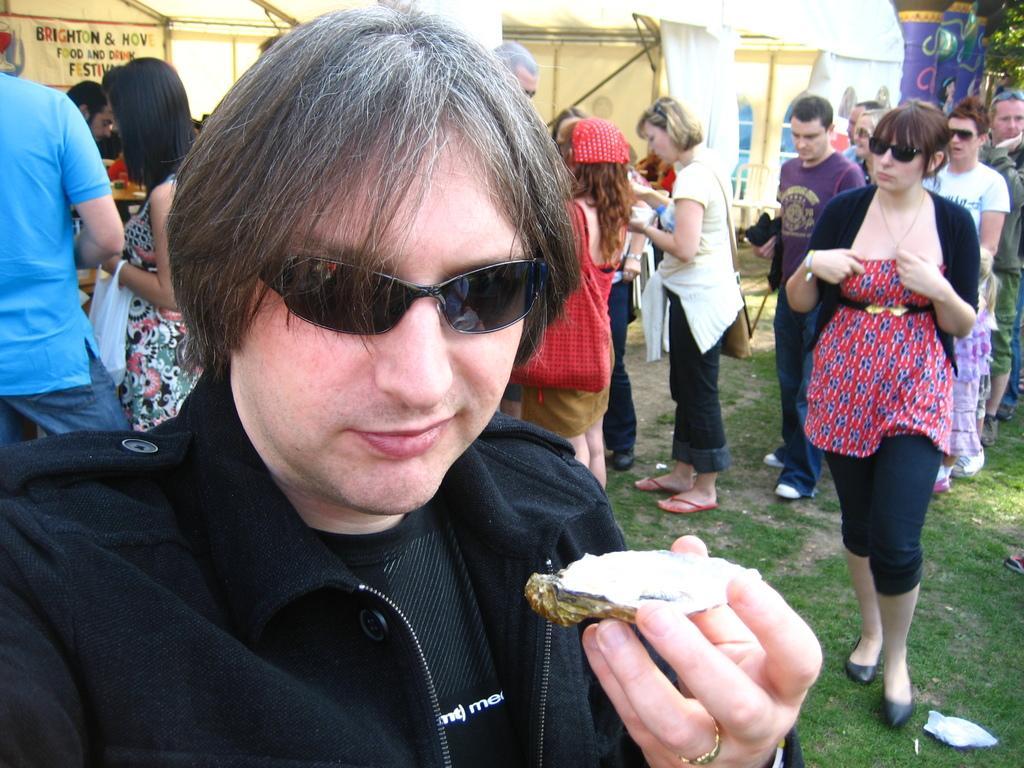Could you give a brief overview of what you see in this image? In this image, we can see persons wearing clothes. There are tents at the top of the image. There is a person at the bottom of the image holding a shell with his hand. There is a grass on the ground. 